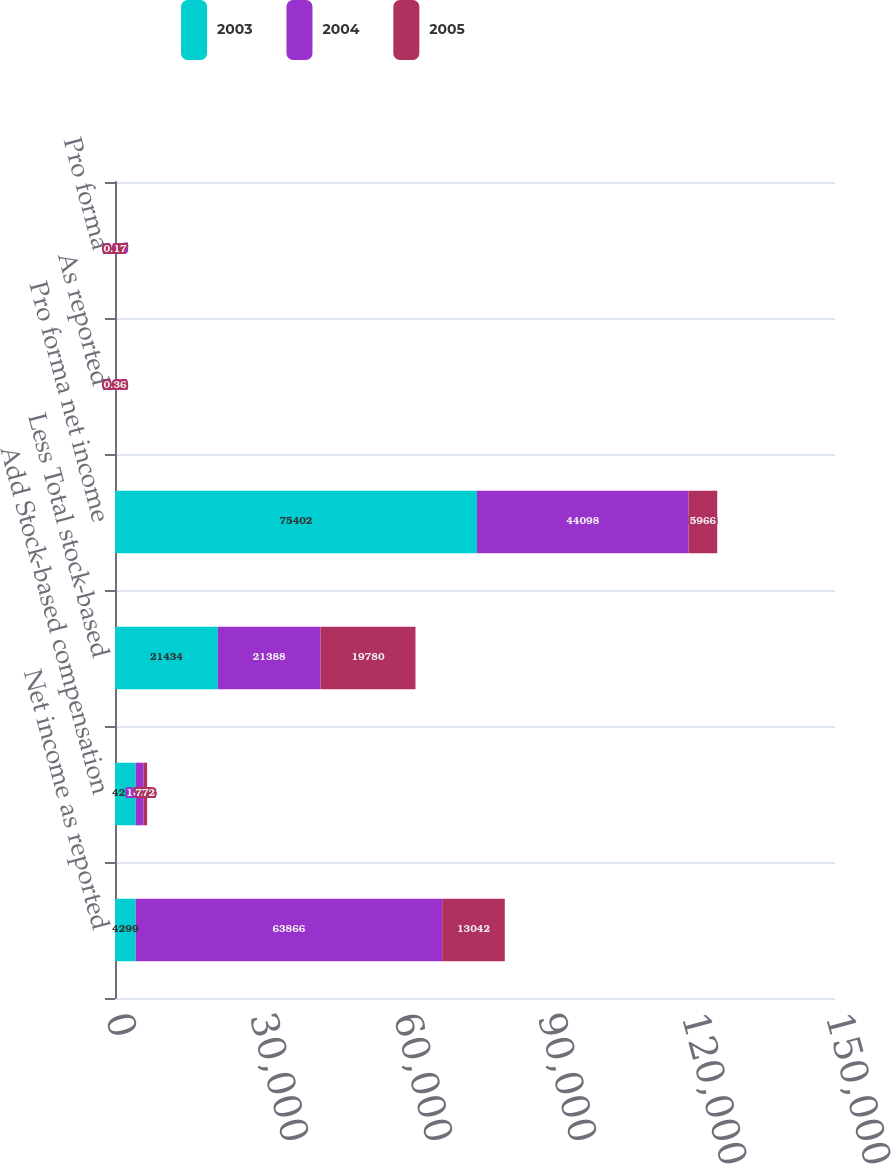<chart> <loc_0><loc_0><loc_500><loc_500><stacked_bar_chart><ecel><fcel>Net income as reported<fcel>Add Stock-based compensation<fcel>Less Total stock-based<fcel>Pro forma net income<fcel>As reported<fcel>Pro forma<nl><fcel>2003<fcel>4299<fcel>4299<fcel>21434<fcel>75402<fcel>2.64<fcel>2.15<nl><fcel>2004<fcel>63866<fcel>1620<fcel>21388<fcel>44098<fcel>1.81<fcel>1.25<nl><fcel>2005<fcel>13042<fcel>772<fcel>19780<fcel>5966<fcel>0.36<fcel>0.17<nl></chart> 